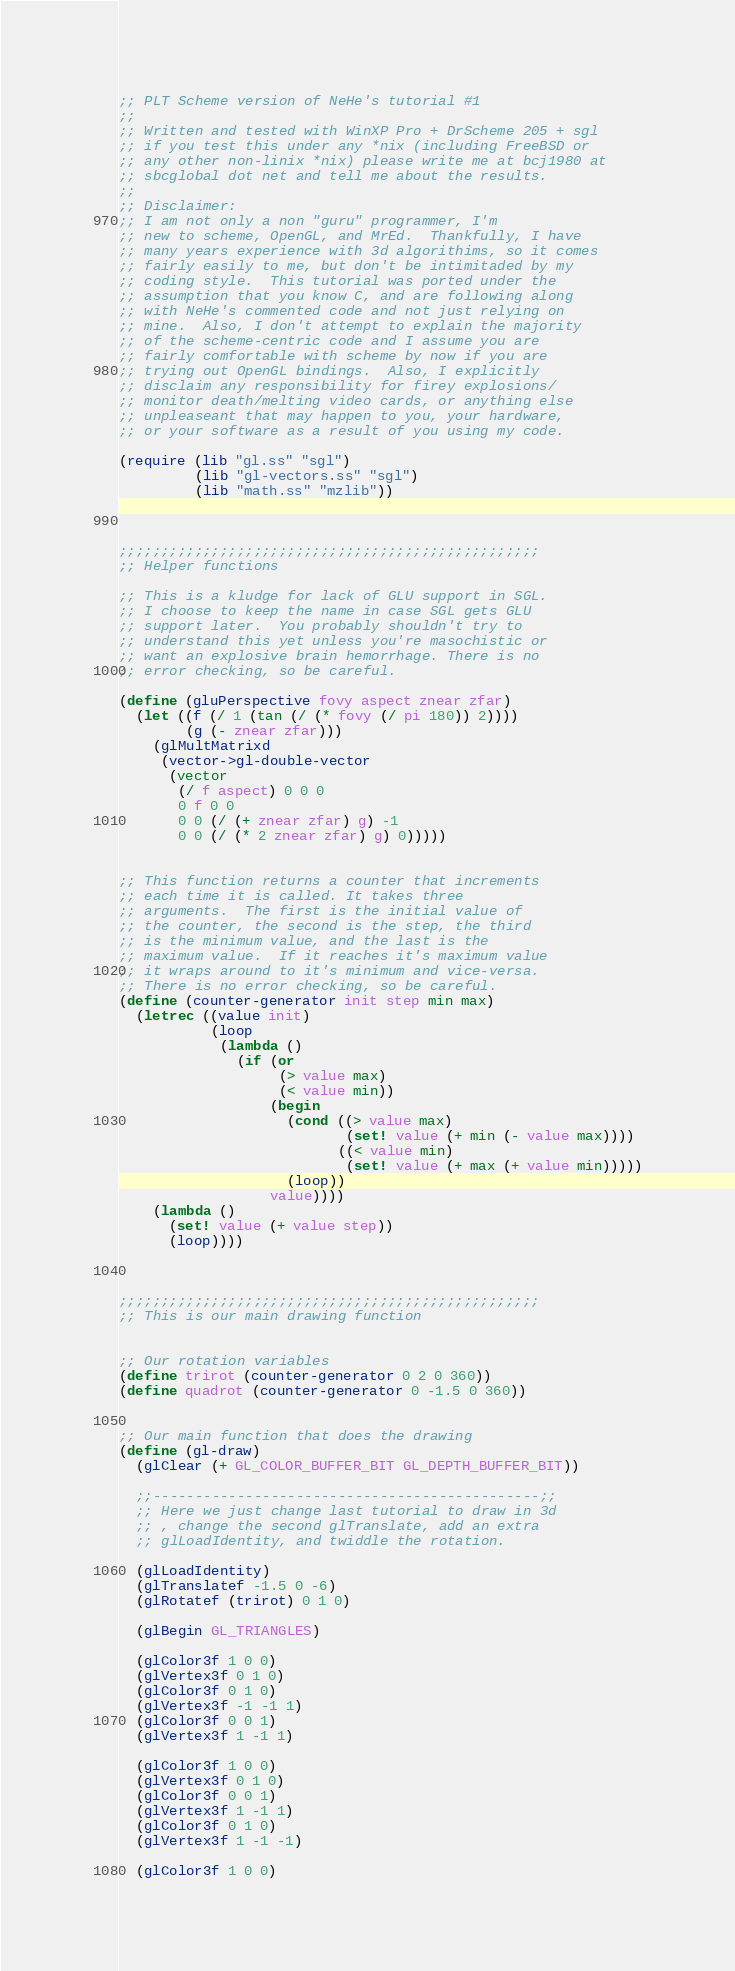Convert code to text. <code><loc_0><loc_0><loc_500><loc_500><_Scheme_>;; PLT Scheme version of NeHe's tutorial #1
;;
;; Written and tested with WinXP Pro + DrScheme 205 + sgl
;; if you test this under any *nix (including FreeBSD or
;; any other non-linix *nix) please write me at bcj1980 at
;; sbcglobal dot net and tell me about the results.
;;
;; Disclaimer:
;; I am not only a non "guru" programmer, I'm
;; new to scheme, OpenGL, and MrEd.  Thankfully, I have
;; many years experience with 3d algorithims, so it comes
;; fairly easily to me, but don't be intimitaded by my
;; coding style.  This tutorial was ported under the
;; assumption that you know C, and are following along
;; with NeHe's commented code and not just relying on
;; mine.  Also, I don't attempt to explain the majority
;; of the scheme-centric code and I assume you are
;; fairly comfortable with scheme by now if you are
;; trying out OpenGL bindings.  Also, I explicitly
;; disclaim any responsibility for firey explosions/
;; monitor death/melting video cards, or anything else
;; unpleaseant that may happen to you, your hardware,
;; or your software as a result of you using my code.

(require (lib "gl.ss" "sgl")
         (lib "gl-vectors.ss" "sgl")
         (lib "math.ss" "mzlib"))



;;;;;;;;;;;;;;;;;;;;;;;;;;;;;;;;;;;;;;;;;;;;;;;;;;
;; Helper functions

;; This is a kludge for lack of GLU support in SGL.
;; I choose to keep the name in case SGL gets GLU
;; support later.  You probably shouldn't try to
;; understand this yet unless you're masochistic or
;; want an explosive brain hemorrhage. There is no
;; error checking, so be careful.

(define (gluPerspective fovy aspect znear zfar)
  (let ((f (/ 1 (tan (/ (* fovy (/ pi 180)) 2))))
        (g (- znear zfar)))
    (glMultMatrixd
     (vector->gl-double-vector
      (vector
       (/ f aspect) 0 0 0
       0 f 0 0
       0 0 (/ (+ znear zfar) g) -1
       0 0 (/ (* 2 znear zfar) g) 0)))))


;; This function returns a counter that increments
;; each time it is called. It takes three
;; arguments.  The first is the initial value of
;; the counter, the second is the step, the third
;; is the minimum value, and the last is the
;; maximum value.  If it reaches it's maximum value
;; it wraps around to it's minimum and vice-versa.
;; There is no error checking, so be careful.
(define (counter-generator init step min max)
  (letrec ((value init)
           (loop
            (lambda ()
              (if (or
                   (> value max)
                   (< value min))
                  (begin
                    (cond ((> value max)
                           (set! value (+ min (- value max))))
                          ((< value min)
                           (set! value (+ max (+ value min)))))
                    (loop))
                  value))))
    (lambda ()
      (set! value (+ value step))
      (loop))))



;;;;;;;;;;;;;;;;;;;;;;;;;;;;;;;;;;;;;;;;;;;;;;;;;;
;; This is our main drawing function


;; Our rotation variables
(define trirot (counter-generator 0 2 0 360))
(define quadrot (counter-generator 0 -1.5 0 360))


;; Our main function that does the drawing
(define (gl-draw)
  (glClear (+ GL_COLOR_BUFFER_BIT GL_DEPTH_BUFFER_BIT))

  ;;----------------------------------------------;;
  ;; Here we just change last tutorial to draw in 3d
  ;; , change the second glTranslate, add an extra
  ;; glLoadIdentity, and twiddle the rotation.

  (glLoadIdentity)
  (glTranslatef -1.5 0 -6)
  (glRotatef (trirot) 0 1 0)

  (glBegin GL_TRIANGLES)

  (glColor3f 1 0 0)
  (glVertex3f 0 1 0)
  (glColor3f 0 1 0)
  (glVertex3f -1 -1 1)
  (glColor3f 0 0 1)
  (glVertex3f 1 -1 1)

  (glColor3f 1 0 0)
  (glVertex3f 0 1 0)
  (glColor3f 0 0 1)
  (glVertex3f 1 -1 1)
  (glColor3f 0 1 0)
  (glVertex3f 1 -1 -1)

  (glColor3f 1 0 0)</code> 